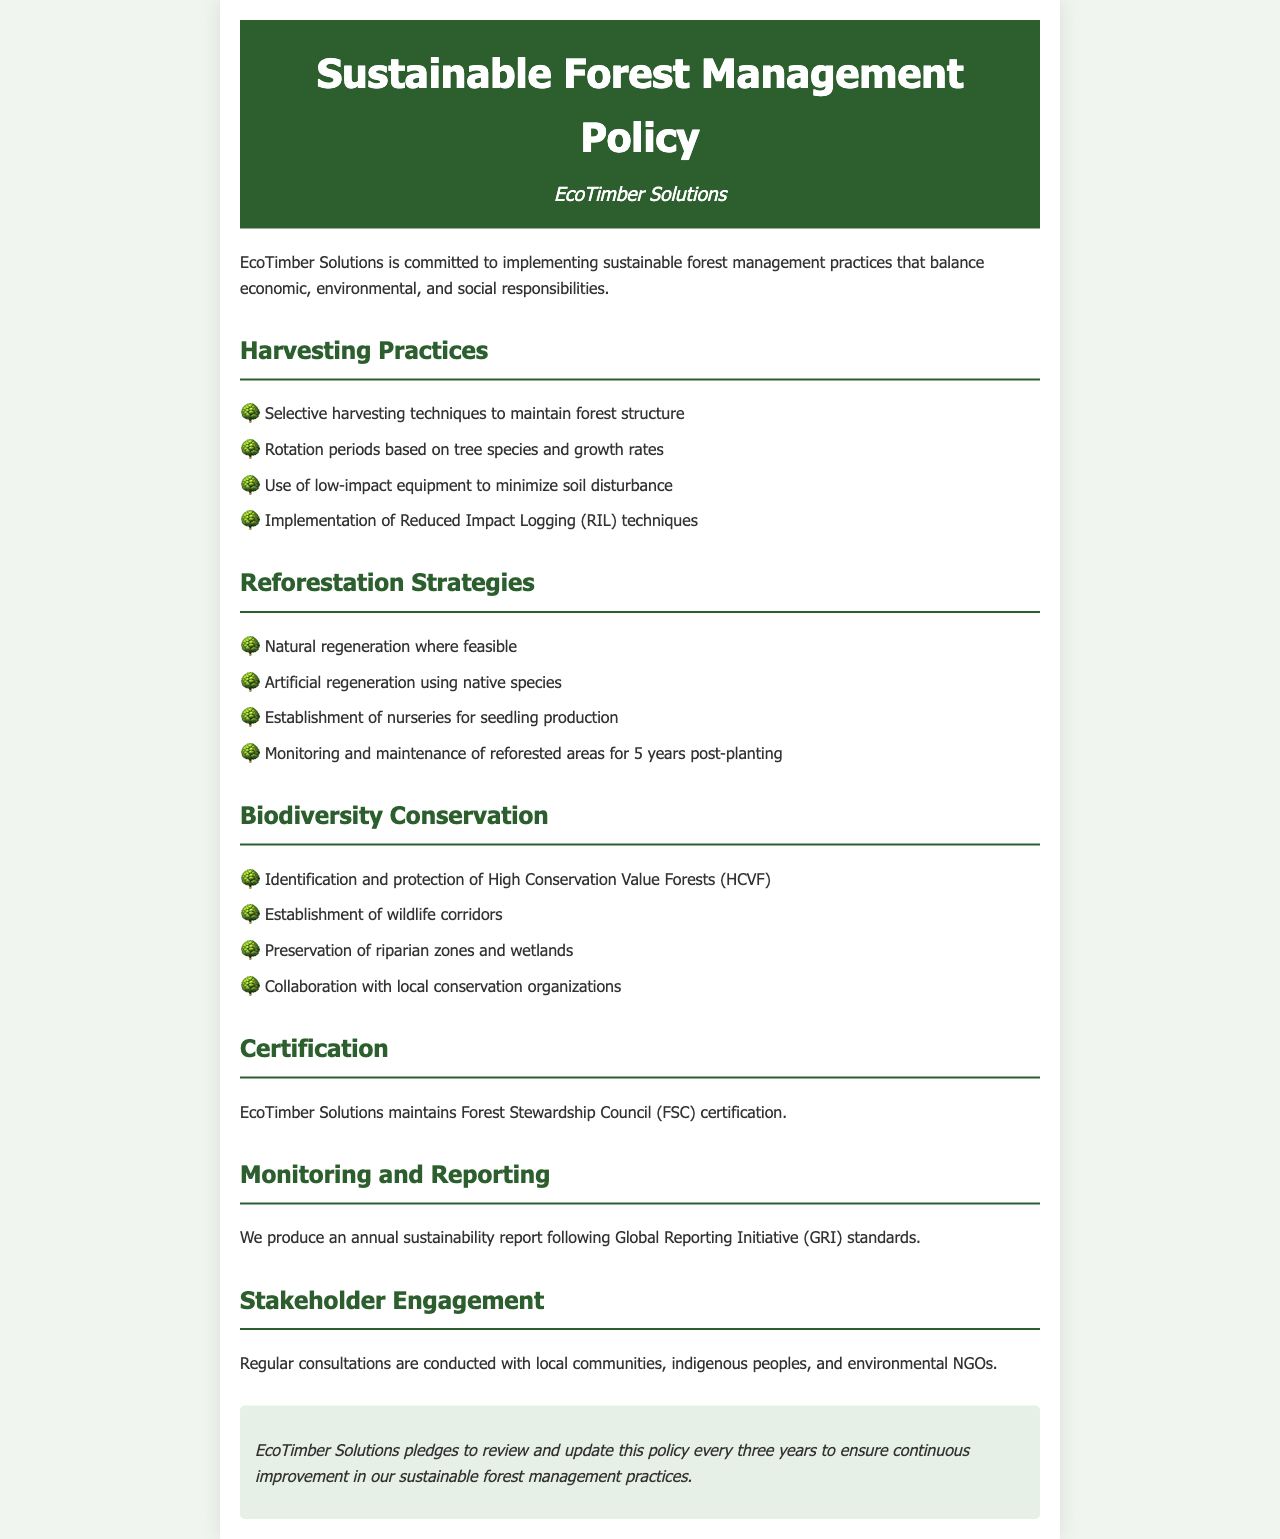What is the name of the company? The name of the company is stated at the top of the document.
Answer: EcoTimber Solutions What harvesting technique does EcoTimber Solutions use? The harvesting technique is listed in the harvesting practices section of the document.
Answer: Selective harvesting techniques What certification does EcoTimber Solutions maintain? This certification is mentioned in the certification section of the document.
Answer: Forest Stewardship Council (FSC) How long is the monitoring period for reforested areas? The monitoring period is specified in the reforestation strategies section of the document.
Answer: 5 years What do wildlife corridors aim to achieve? The goal of establishing wildlife corridors is implied in the biodiversity conservation section.
Answer: Protection of wildlife How often is the policy reviewed and updated? The frequency of the review is mentioned in the commitment section.
Answer: Every three years What standard does EcoTimber Solutions follow for their sustainability report? The standard for the sustainability report is indicated in the monitoring and reporting section.
Answer: Global Reporting Initiative (GRI) Which zones are preserved as part of biodiversity conservation? The preserved zones are listed in the biodiversity conservation section of the document.
Answer: Riparian zones and wetlands What type of regeneration is prioritized when feasible? The type of regeneration is noted in the reforestation strategies section.
Answer: Natural regeneration 